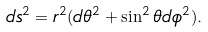Convert formula to latex. <formula><loc_0><loc_0><loc_500><loc_500>d s ^ { 2 } = r ^ { 2 } ( d \theta ^ { 2 } + \sin ^ { 2 } \theta d \phi ^ { 2 } ) .</formula> 